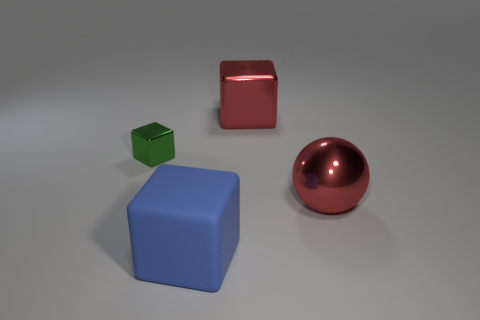Subtract all big blocks. How many blocks are left? 1 Add 4 small red metallic cubes. How many objects exist? 8 Subtract all balls. How many objects are left? 3 Subtract all red blocks. How many blocks are left? 2 Subtract 0 yellow balls. How many objects are left? 4 Subtract 1 blocks. How many blocks are left? 2 Subtract all cyan cubes. Subtract all cyan spheres. How many cubes are left? 3 Subtract all gray matte cubes. Subtract all large metallic things. How many objects are left? 2 Add 3 large blue matte cubes. How many large blue matte cubes are left? 4 Add 2 blocks. How many blocks exist? 5 